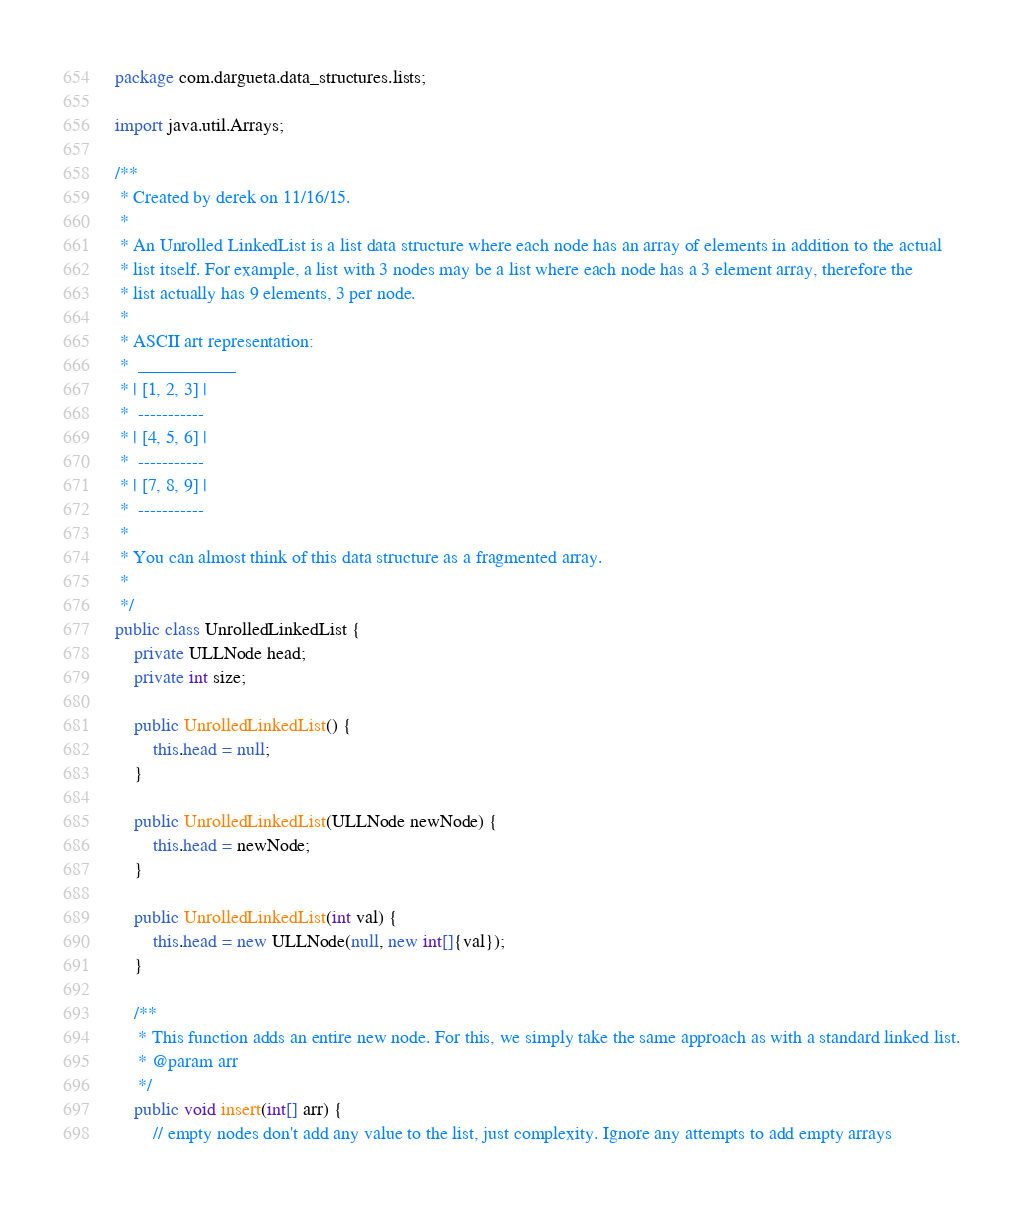Convert code to text. <code><loc_0><loc_0><loc_500><loc_500><_Java_>package com.dargueta.data_structures.lists;

import java.util.Arrays;

/**
 * Created by derek on 11/16/15.
 *
 * An Unrolled LinkedList is a list data structure where each node has an array of elements in addition to the actual
 * list itself. For example, a list with 3 nodes may be a list where each node has a 3 element array, therefore the
 * list actually has 9 elements, 3 per node.
 *
 * ASCII art representation:
 *  ___________
 * | [1, 2, 3] |
 *  -----------
 * | [4, 5, 6] |
 *  -----------
 * | [7, 8, 9] |
 *  -----------
 *
 * You can almost think of this data structure as a fragmented array.
 *
 */
public class UnrolledLinkedList {
    private ULLNode head;
    private int size;

    public UnrolledLinkedList() {
        this.head = null;
    }

    public UnrolledLinkedList(ULLNode newNode) {
        this.head = newNode;
    }

    public UnrolledLinkedList(int val) {
        this.head = new ULLNode(null, new int[]{val});
    }

    /**
     * This function adds an entire new node. For this, we simply take the same approach as with a standard linked list.
     * @param arr
     */
    public void insert(int[] arr) {
        // empty nodes don't add any value to the list, just complexity. Ignore any attempts to add empty arrays</code> 